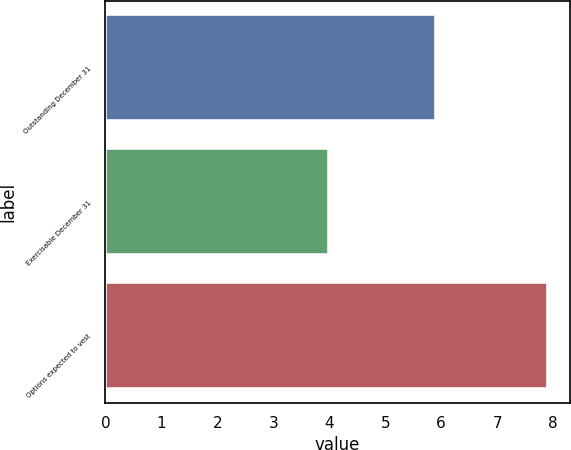<chart> <loc_0><loc_0><loc_500><loc_500><bar_chart><fcel>Outstanding December 31<fcel>Exercisable December 31<fcel>Options expected to vest<nl><fcel>5.9<fcel>4<fcel>7.9<nl></chart> 